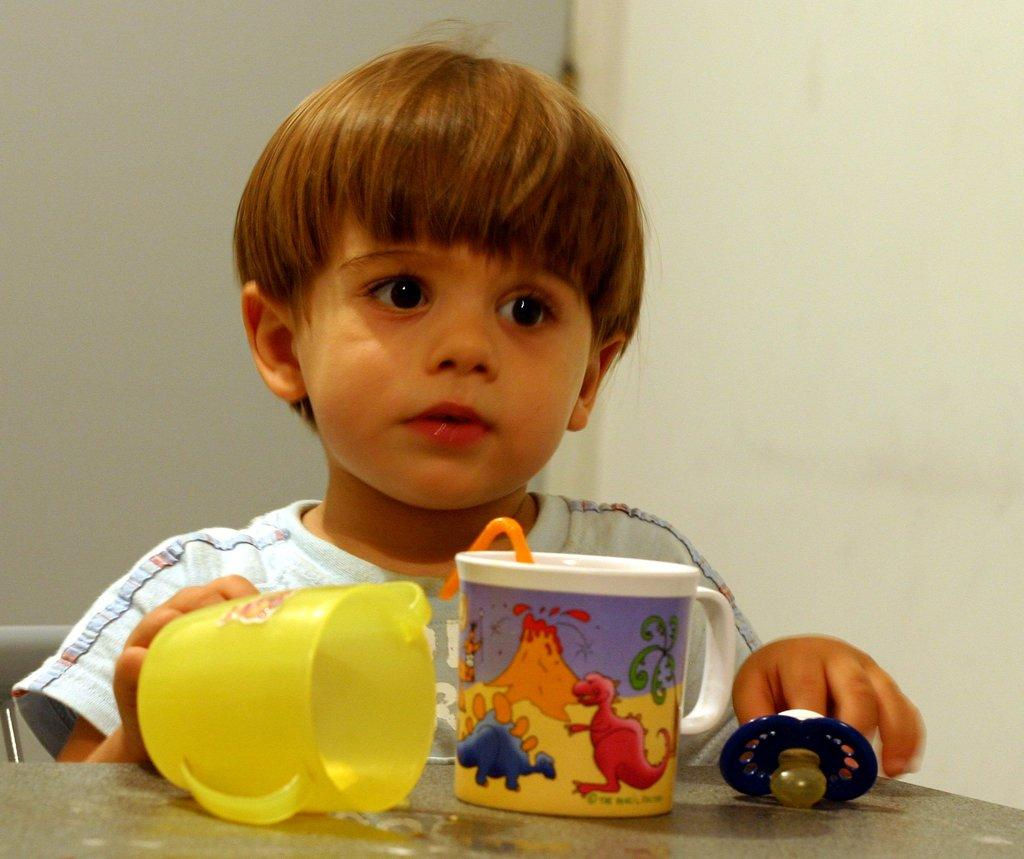What is the kid doing in the image? The kid is sitting on a chair in the image. What object is on the table in the image? There is a cup on the table in the image. What other item is on the table in the image? There is a cap on the table in the image. What type of hair can be seen hanging from the cap in the image? There is no hair present in the image, as the cap is not attached to a person's head. 